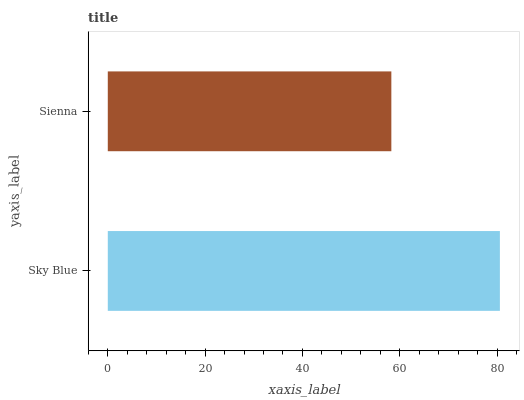Is Sienna the minimum?
Answer yes or no. Yes. Is Sky Blue the maximum?
Answer yes or no. Yes. Is Sienna the maximum?
Answer yes or no. No. Is Sky Blue greater than Sienna?
Answer yes or no. Yes. Is Sienna less than Sky Blue?
Answer yes or no. Yes. Is Sienna greater than Sky Blue?
Answer yes or no. No. Is Sky Blue less than Sienna?
Answer yes or no. No. Is Sky Blue the high median?
Answer yes or no. Yes. Is Sienna the low median?
Answer yes or no. Yes. Is Sienna the high median?
Answer yes or no. No. Is Sky Blue the low median?
Answer yes or no. No. 